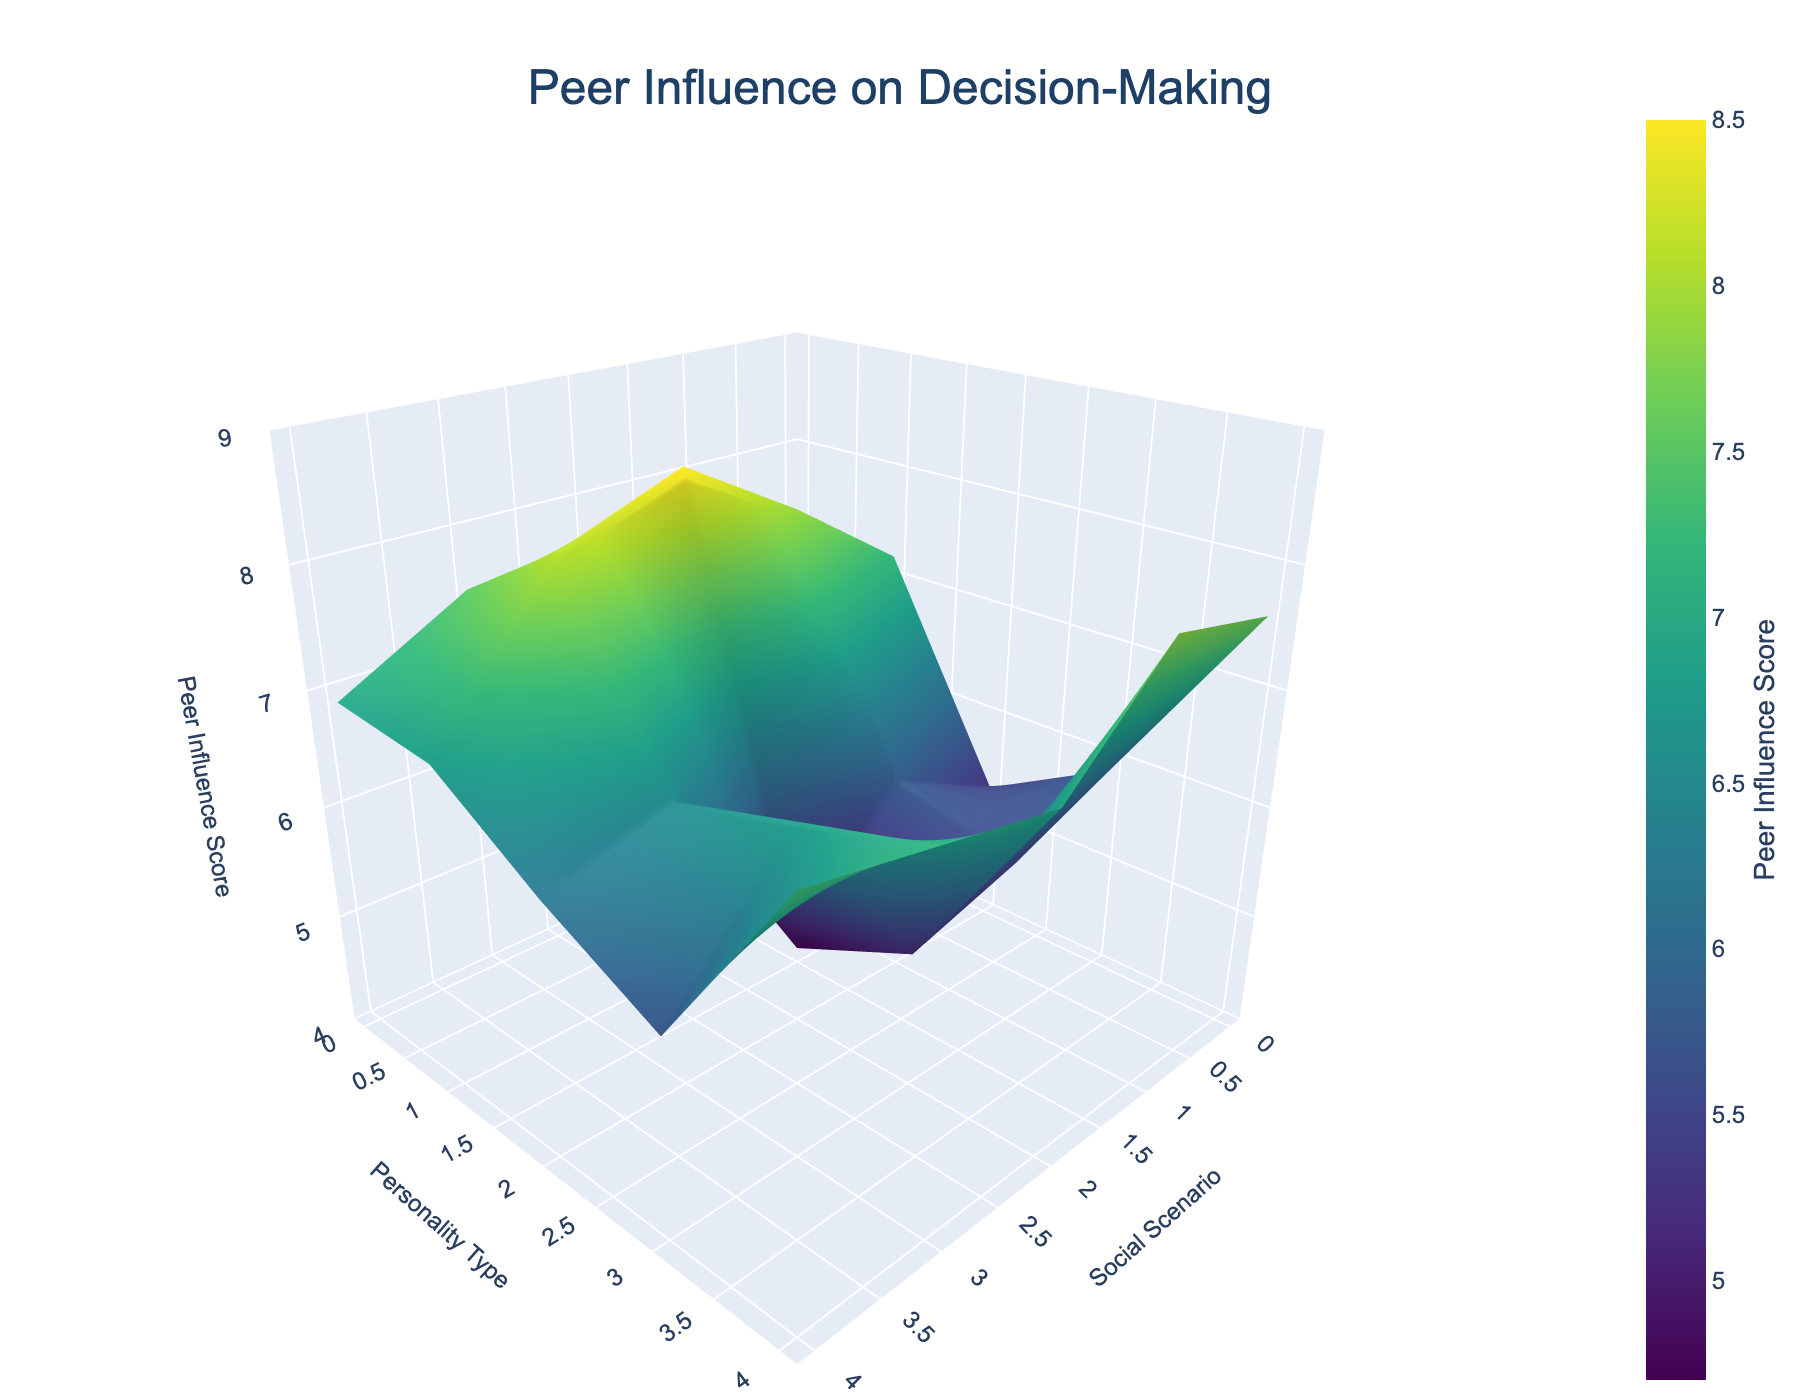What's the title of the plot? The plot title is usually prominently displayed at the top of the figure. In this case, the title is "Peer Influence on Decision-Making."
Answer: Peer Influence on Decision-Making What do the colors on the surface represent? Colors typically represent the values on the z-axis. Here, they correspond to the Peer Influence Score, with the colors changing along the Viridis color scale.
Answer: Peer Influence Score Which personality type has the highest peer influence score in the "Party Attendance" scenario? Locate the "Party Attendance" scenario on the x-axis and then trace upwards to find the highest z value, noting the corresponding personality type on the y-axis. Extrovert has the highest score for "Party Attendance."
Answer: Extrovert What's the difference in peer influence score between Extroverts and Introverts in "Classroom Discussion"? Compare the z-values for Extroverts and Introverts under "Classroom Discussion". Extroverts have a score of 7.2 and Introverts have a score of 5.3. So, 7.2 - 5.3 = 1.9.
Answer: 1.9 What is the general trend of peer influence scores for Ambiverts across different social scenarios? Inspect the surface corresponding to Ambiverts across various scenarios to identify the trend. The scores tend to range between 6.4 and 7.5, showing a relatively consistent moderate to high influence.
Answer: Moderate to high, relatively consistent Which social scenario shows the highest overall peer influence score? Identify the highest z value across the entire plot and trace it back to the corresponding social scenario on the x-axis. "Party Attendance" has the highest score noticeable on the plot.
Answer: Party Attendance Compare the peer influence scores of Neuroticism and Openness in "Club Membership." Which is higher? Compare the z-values for Neuroticism and Openness under the "Club Membership" scenario. Neuroticism has a score of 5.5, while Openness has 7.8, so Openness is higher.
Answer: Openness What is the range of peer influence scores visible in the plot? Examine the color bar and the z-axis to determine the minimum and maximum values. The range is from about 4 to 9.
Answer: 4 to 9 If you had to predict, which personality type is most resistant to peer influence based on the provided scenarios? Observe the overall lower z-values across all scenarios for different personality types. Introverts generally have the lowest scores, indicating they might be the most resistant to peer influence.
Answer: Introverts 